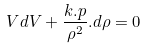Convert formula to latex. <formula><loc_0><loc_0><loc_500><loc_500>V d V + \frac { k . p } { \rho ^ { 2 } } . d \rho = 0</formula> 